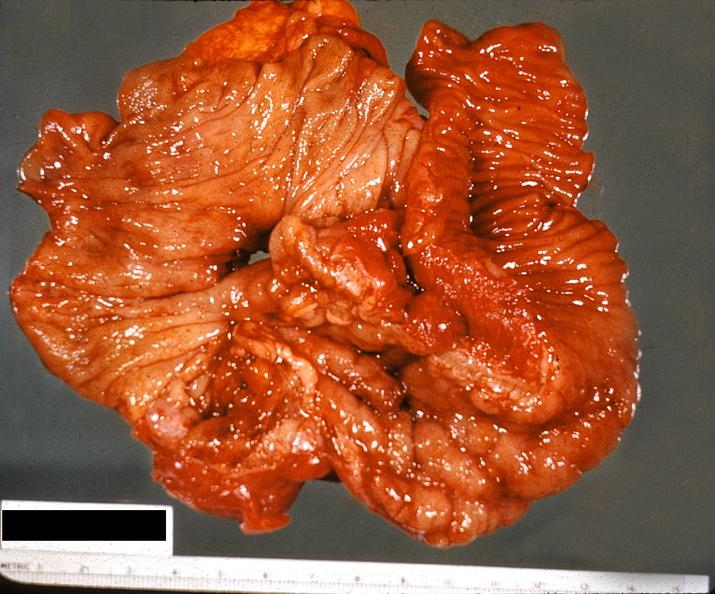where does this belong to?
Answer the question using a single word or phrase. Gastrointestinal system 